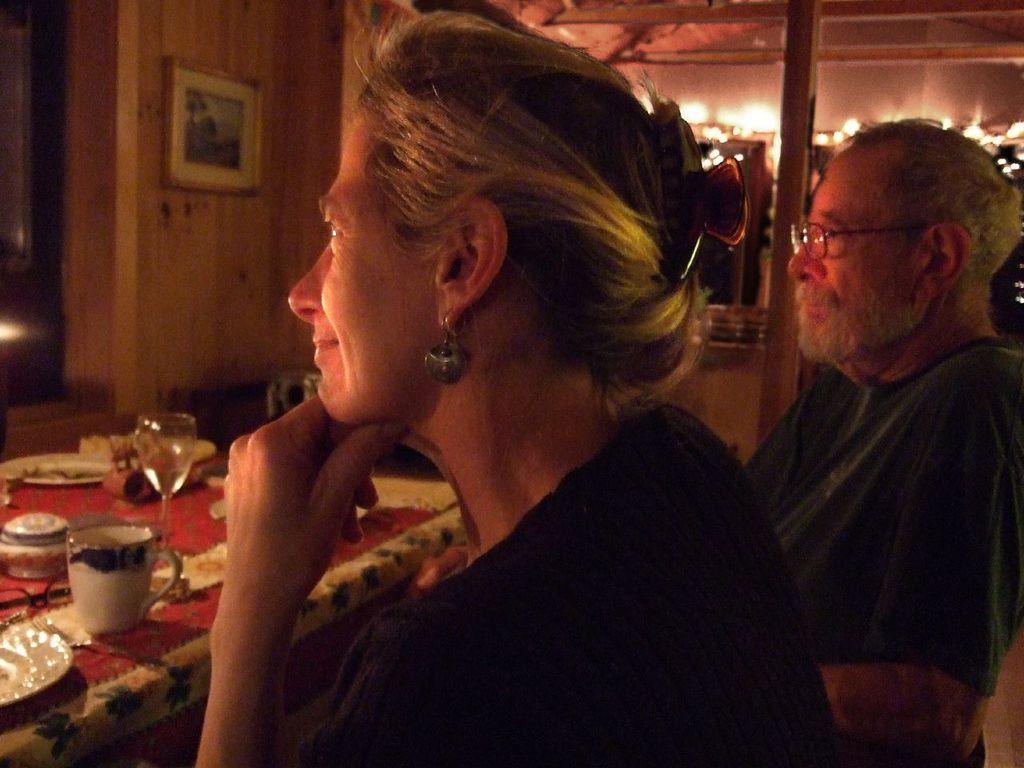Can you describe this image briefly? In front of the image there is a lady sitting. Beside her there is a man with spectacles is sitting. In front of them there is a table with a cup, glass, plate and some other items. In the background there is a wall with frame and also there are lights. 